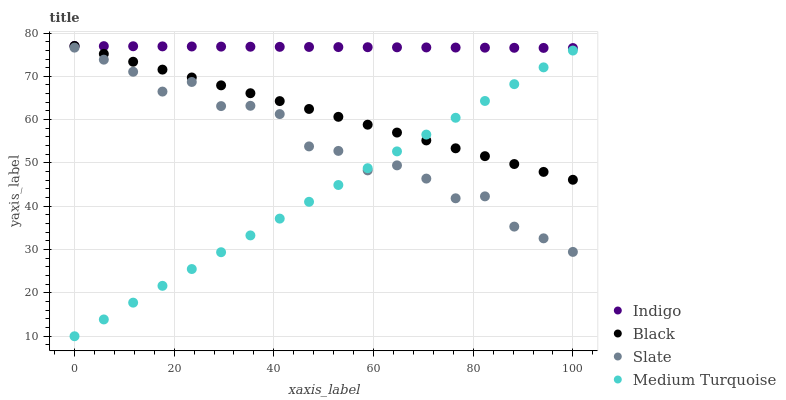Does Medium Turquoise have the minimum area under the curve?
Answer yes or no. Yes. Does Indigo have the maximum area under the curve?
Answer yes or no. Yes. Does Slate have the minimum area under the curve?
Answer yes or no. No. Does Slate have the maximum area under the curve?
Answer yes or no. No. Is Black the smoothest?
Answer yes or no. Yes. Is Slate the roughest?
Answer yes or no. Yes. Is Indigo the smoothest?
Answer yes or no. No. Is Indigo the roughest?
Answer yes or no. No. Does Medium Turquoise have the lowest value?
Answer yes or no. Yes. Does Slate have the lowest value?
Answer yes or no. No. Does Indigo have the highest value?
Answer yes or no. Yes. Does Slate have the highest value?
Answer yes or no. No. Is Slate less than Indigo?
Answer yes or no. Yes. Is Indigo greater than Slate?
Answer yes or no. Yes. Does Indigo intersect Black?
Answer yes or no. Yes. Is Indigo less than Black?
Answer yes or no. No. Is Indigo greater than Black?
Answer yes or no. No. Does Slate intersect Indigo?
Answer yes or no. No. 